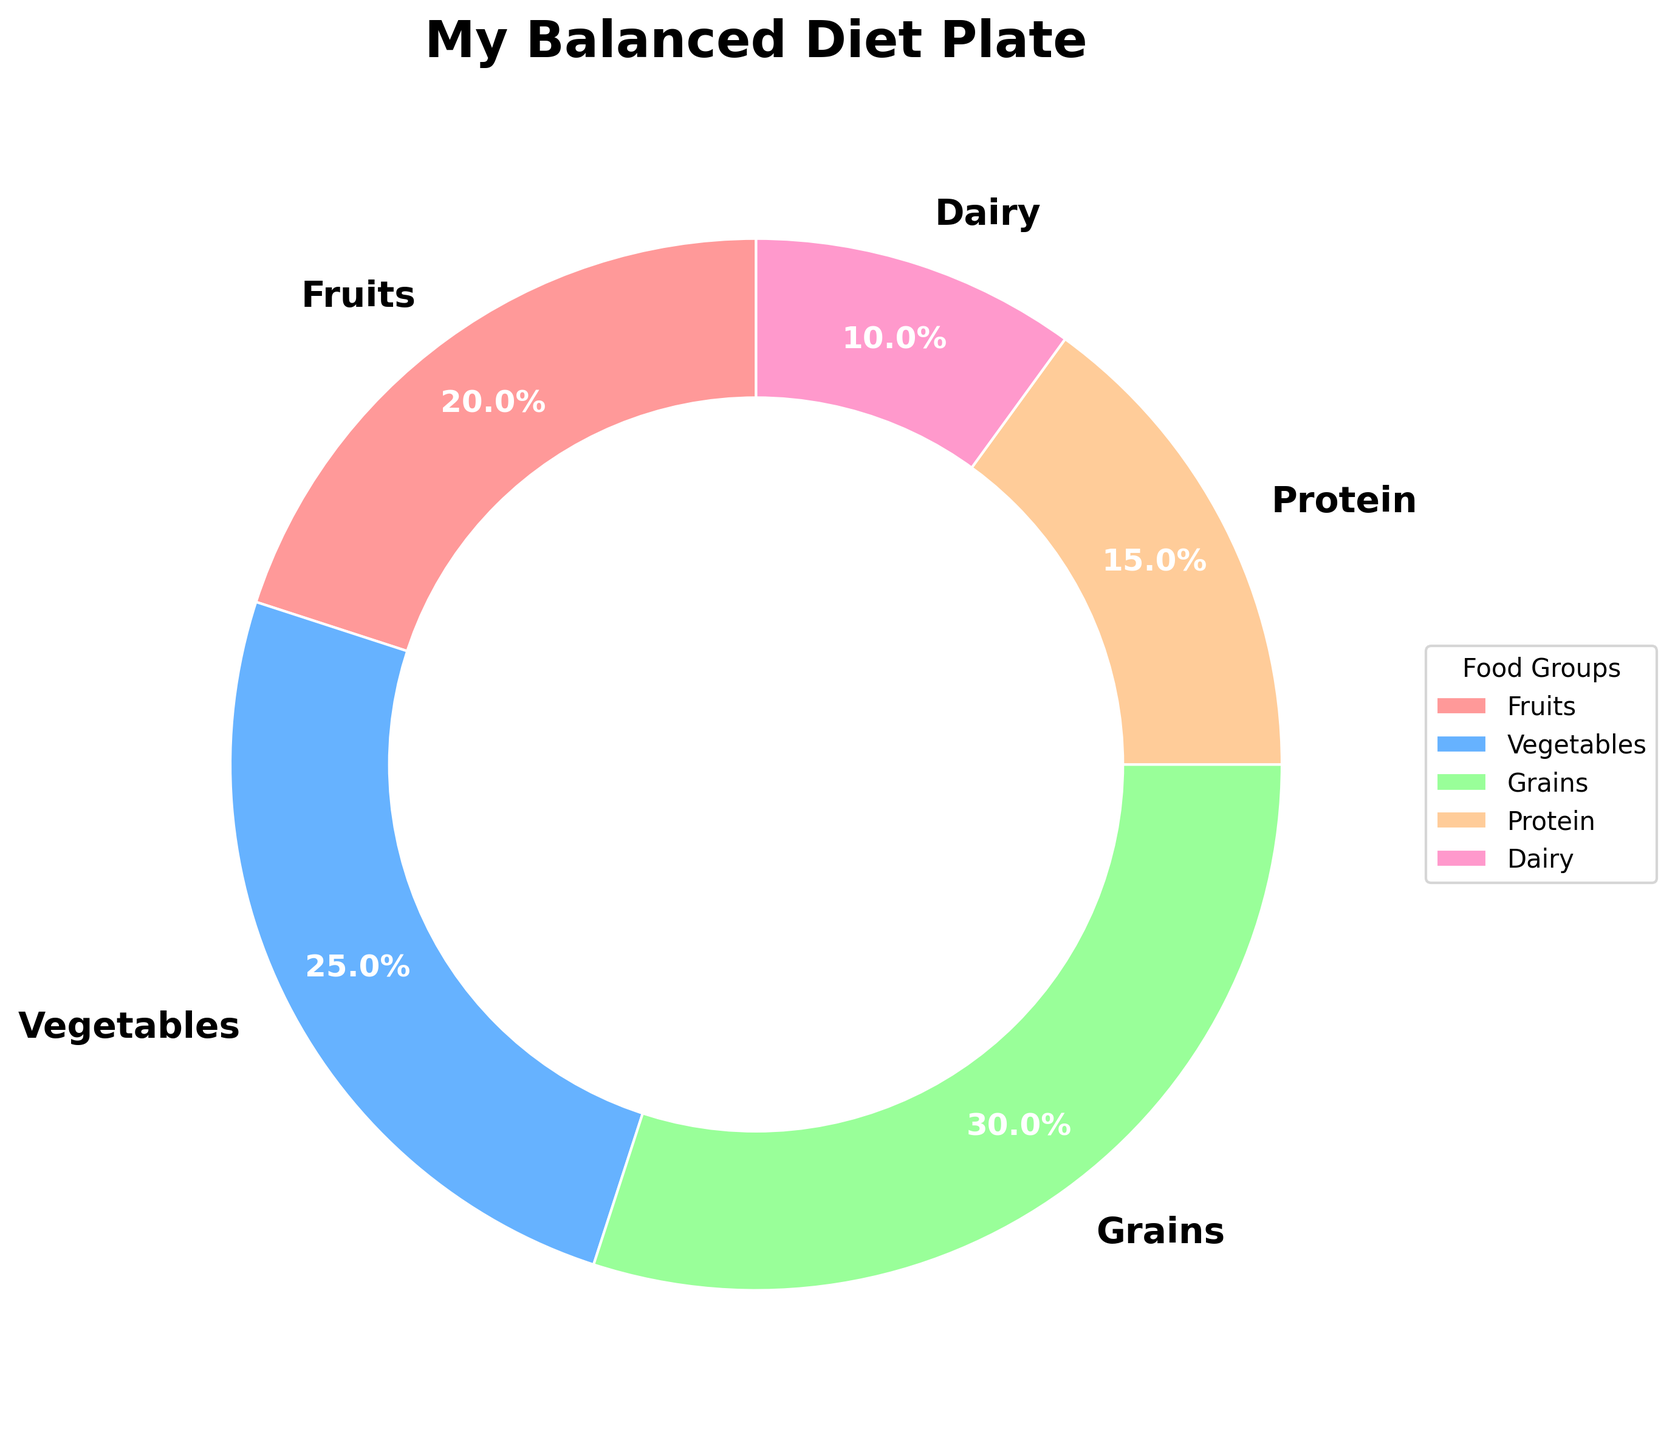Which food group is represented by the smallest section of the pie chart? To find the smallest section, look at each segment of the pie chart and identify the one with the least percentage. The segment representing Dairy is the smallest with a 10% share.
Answer: Dairy How much more percentage do Vegetables have compared to Protein? Locate the segments for Vegetables and Protein. Vegetables have 25% and Protein has 15%. Subtract Protein's percentage from Vegetables' (25% - 15% = 10%).
Answer: 10% What is the combined percentage of Fruits and Grains? Locate the segments for Fruits and Grains. Fruits have 20%, and Grains have 30%. Add these percentages together (20% + 30% = 50%).
Answer: 50% Is the percentage of Grains greater than the combined percentage of Dairy and Protein? Locate the segments for Grains, Dairy, and Protein. Grains have 30%. Dairy and Protein together have (10% + 15% = 25%). Compare 30% (Grains) with 25% (Dairy + Protein) to see that 30% is greater.
Answer: Yes What color represents the Fruits segment in the pie chart? Identify the color used for the Fruits segment by comparing it to the legend. The segment for Fruits is represented by a light red color.
Answer: Light red How does the percentage of Fruits compare to the percentage of Vegetables? Locate the segments for Fruits and Vegetables. Fruits have 20% and Vegetables have 25%. Compare the two percentages and see that Vegetables (25%) are greater than Fruits (20%).
Answer: Vegetables are greater What's the ratio of the percentage of Grains to Dairy? Locate the segments for Grains and Dairy. Grains have 30%, and Dairy has 10%. The ratio is found by dividing Grains' percentage by Dairy's (30% / 10% = 3).
Answer: 3:1 How many more percent does Grains have than Fruits? Locate Grains and Fruits segments. Grains have 30%, and Fruits have 20%. Subtract Fruits' percentage from Grains' (30% - 20% = 10%).
Answer: 10% 